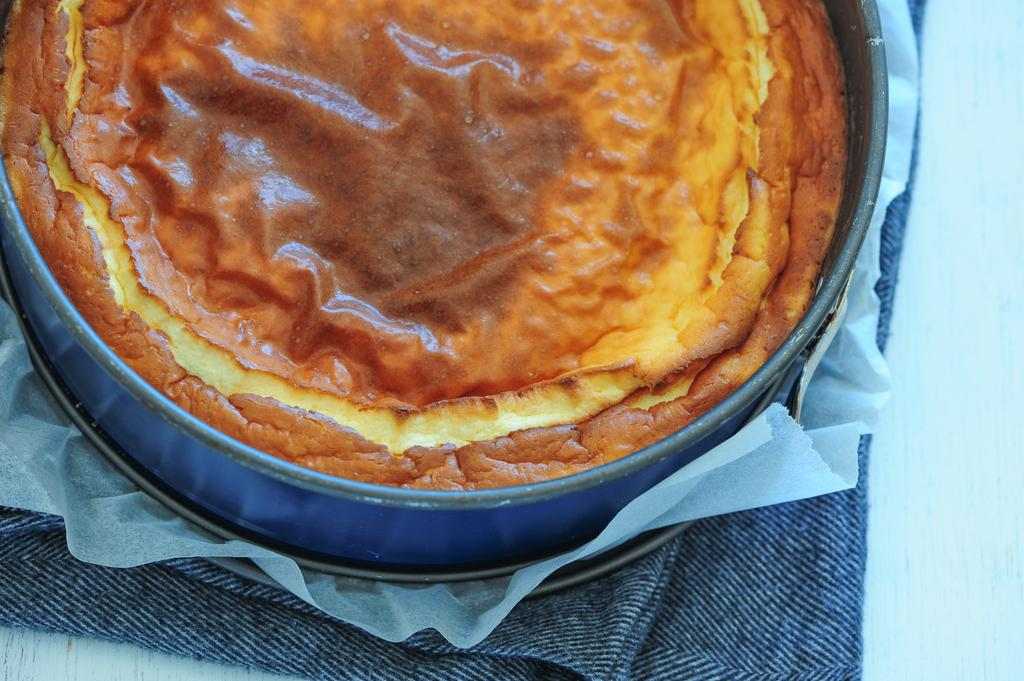Where was the image taken? The image was taken indoors. What furniture is present in the image? There is a table in the image. What items are on the table? There is a napkin, a butter paper, a plate, and a bowl with cake on the table. What type of snail can be seen crawling on the cake in the image? There are no snails present in the image; it only shows a bowl with cake on the table. 